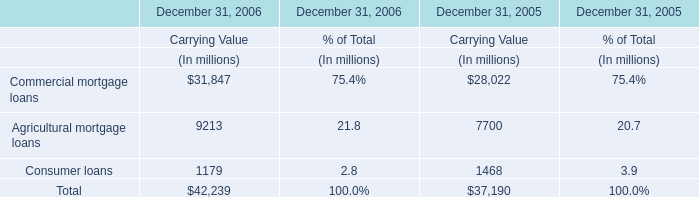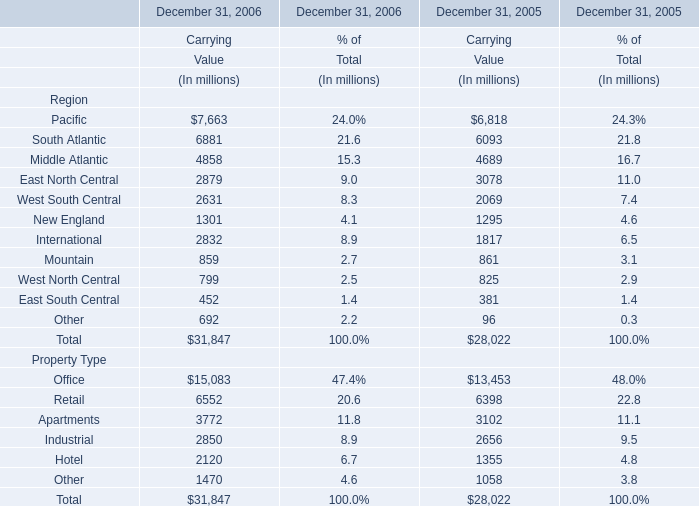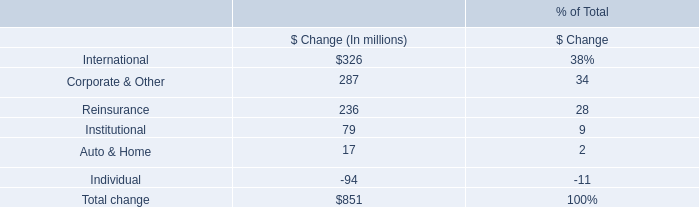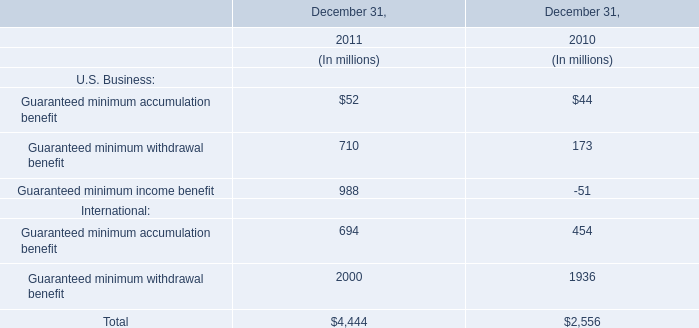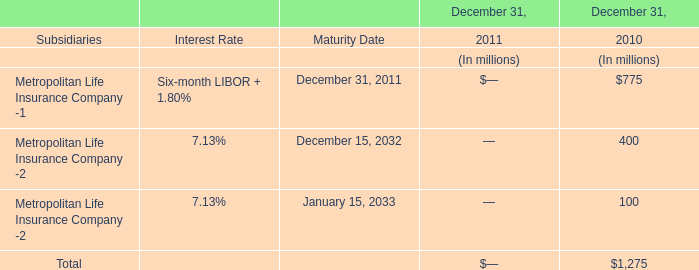In the year with highest amount of Agricultural mortgage loans at Carrying Value, what's the increasing rate of Carrying Value of Commercial mortgage loans? 
Computations: ((31847 - 28022) / 28022)
Answer: 0.1365. 